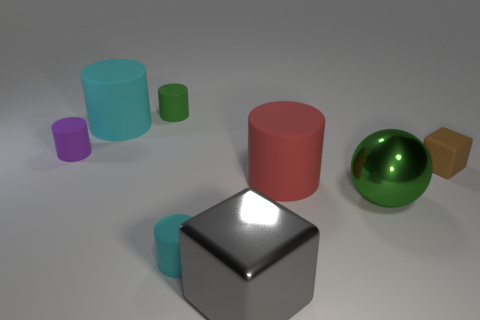Subtract all purple cylinders. How many cylinders are left? 4 Subtract all large cyan matte cylinders. How many cylinders are left? 4 Subtract all red blocks. Subtract all purple spheres. How many blocks are left? 2 Add 2 small gray matte spheres. How many objects exist? 10 Subtract all balls. How many objects are left? 7 Subtract all green things. Subtract all small cylinders. How many objects are left? 3 Add 6 spheres. How many spheres are left? 7 Add 3 small green cylinders. How many small green cylinders exist? 4 Subtract 0 blue blocks. How many objects are left? 8 